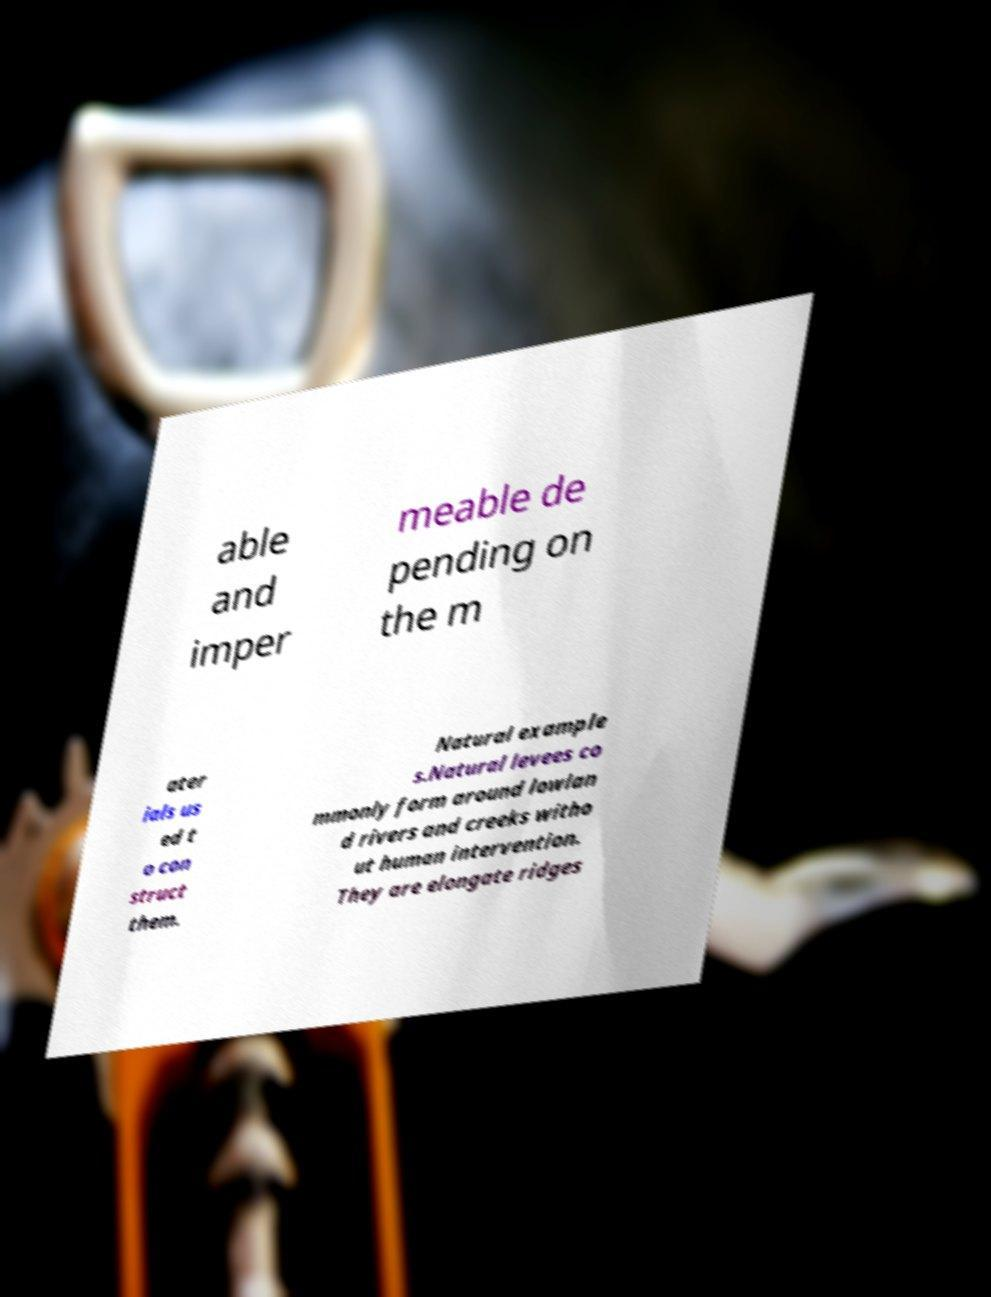Can you accurately transcribe the text from the provided image for me? able and imper meable de pending on the m ater ials us ed t o con struct them. Natural example s.Natural levees co mmonly form around lowlan d rivers and creeks witho ut human intervention. They are elongate ridges 